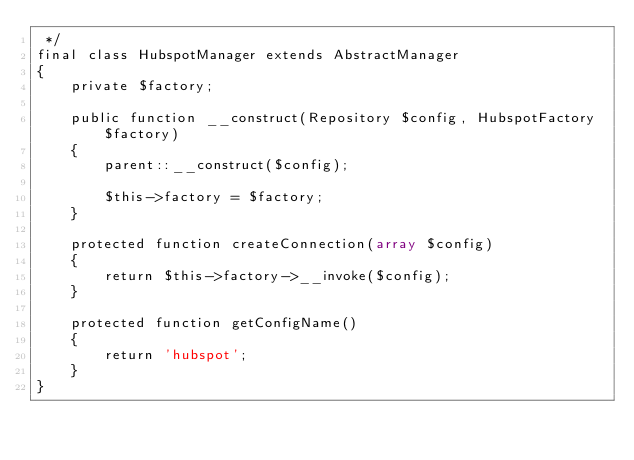Convert code to text. <code><loc_0><loc_0><loc_500><loc_500><_PHP_> */
final class HubspotManager extends AbstractManager
{
    private $factory;

    public function __construct(Repository $config, HubspotFactory $factory)
    {
        parent::__construct($config);

        $this->factory = $factory;
    }

    protected function createConnection(array $config)
    {
        return $this->factory->__invoke($config);
    }

    protected function getConfigName()
    {
        return 'hubspot';
    }
}
</code> 